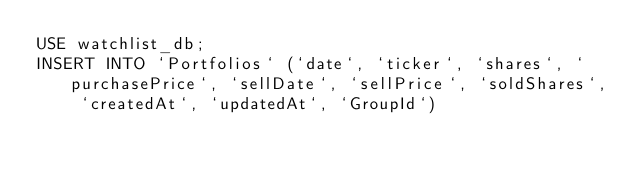Convert code to text. <code><loc_0><loc_0><loc_500><loc_500><_SQL_>USE watchlist_db;
INSERT INTO `Portfolios` (`date`, `ticker`, `shares`, `purchasePrice`, `sellDate`, `sellPrice`, `soldShares`, `createdAt`, `updatedAt`, `GroupId`) </code> 